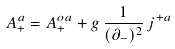Convert formula to latex. <formula><loc_0><loc_0><loc_500><loc_500>A ^ { a } _ { + } = A ^ { o a } _ { + } + g \, \frac { 1 } { ( \partial _ { - } ) ^ { 2 } } \, j ^ { + a }</formula> 